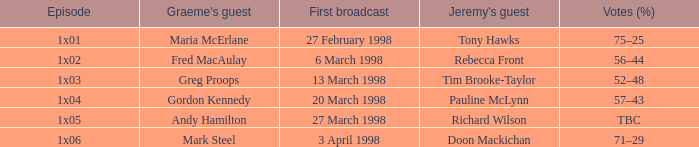Parse the full table. {'header': ['Episode', "Graeme's guest", 'First broadcast', "Jeremy's guest", 'Votes (%)'], 'rows': [['1x01', 'Maria McErlane', '27 February 1998', 'Tony Hawks', '75–25'], ['1x02', 'Fred MacAulay', '6 March 1998', 'Rebecca Front', '56–44'], ['1x03', 'Greg Proops', '13 March 1998', 'Tim Brooke-Taylor', '52–48'], ['1x04', 'Gordon Kennedy', '20 March 1998', 'Pauline McLynn', '57–43'], ['1x05', 'Andy Hamilton', '27 March 1998', 'Richard Wilson', 'TBC'], ['1x06', 'Mark Steel', '3 April 1998', 'Doon Mackichan', '71–29']]} What is First Broadcast, when Jeremy's Guest is "Tim Brooke-Taylor"? 13 March 1998. 